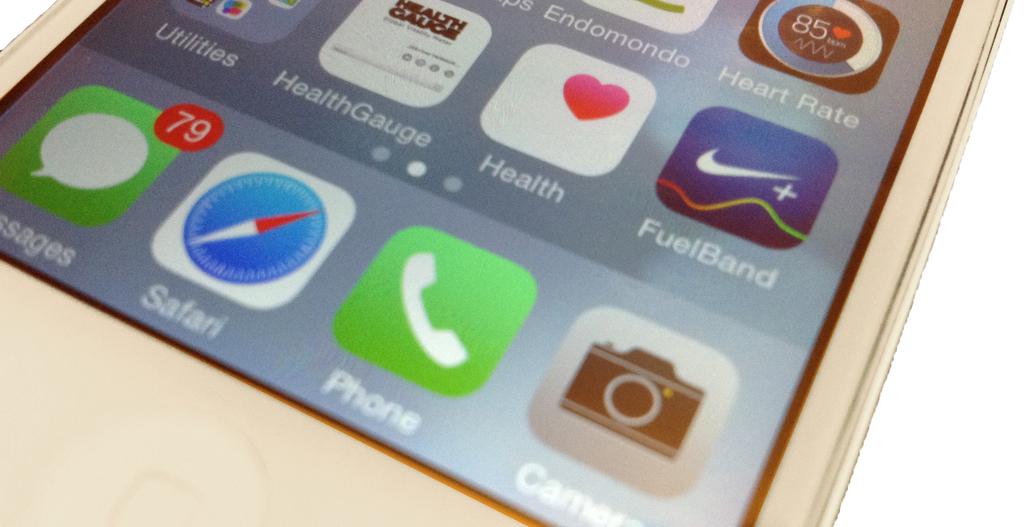What is under the green icon?
Ensure brevity in your answer.  Phone. What is under the camera icon?
Your response must be concise. Camera. 